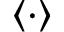<formula> <loc_0><loc_0><loc_500><loc_500>\langle \cdot \rangle</formula> 